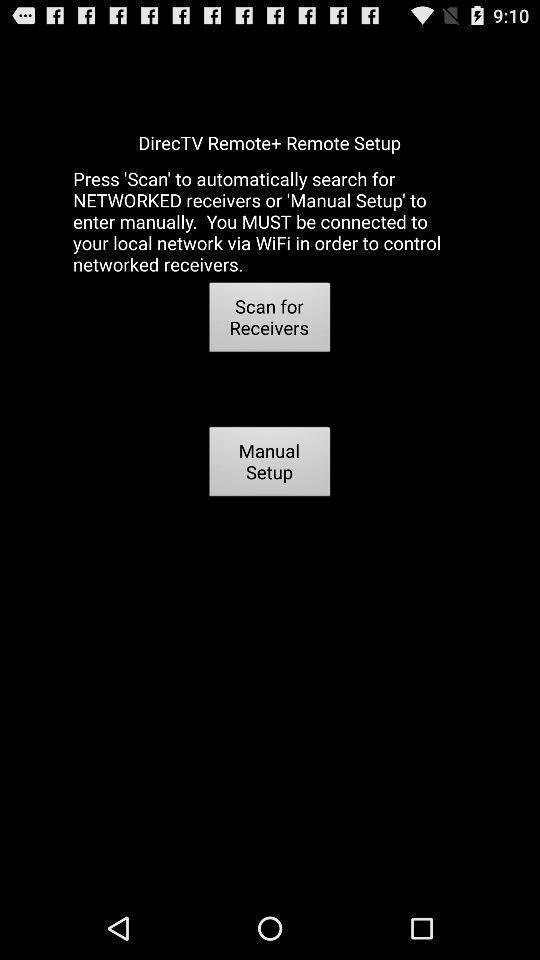What is the overall content of this screenshot? Page shows the different options to scan for network receivers. 